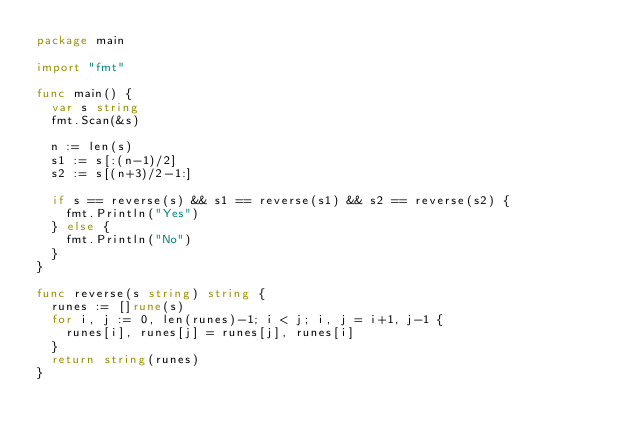<code> <loc_0><loc_0><loc_500><loc_500><_Go_>package main

import "fmt"

func main() {
	var s string
	fmt.Scan(&s)

	n := len(s)
	s1 := s[:(n-1)/2]
	s2 := s[(n+3)/2-1:]

	if s == reverse(s) && s1 == reverse(s1) && s2 == reverse(s2) {
		fmt.Println("Yes")
	} else {
		fmt.Println("No")
	}
}

func reverse(s string) string {
	runes := []rune(s)
	for i, j := 0, len(runes)-1; i < j; i, j = i+1, j-1 {
		runes[i], runes[j] = runes[j], runes[i]
	}
	return string(runes)
}
</code> 